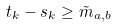<formula> <loc_0><loc_0><loc_500><loc_500>t _ { k } - s _ { k } \geq \tilde { m } _ { a , b }</formula> 